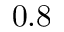<formula> <loc_0><loc_0><loc_500><loc_500>0 . 8</formula> 